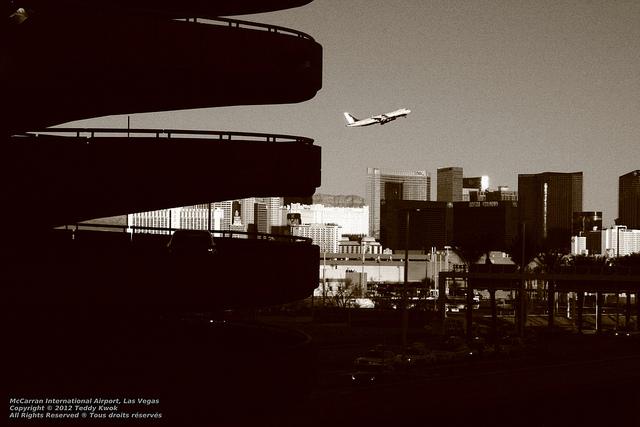Is this photo in color?
Quick response, please. No. Are there clouds visible?
Short answer required. No. What type of transportation do you see?
Keep it brief. Airplane. 